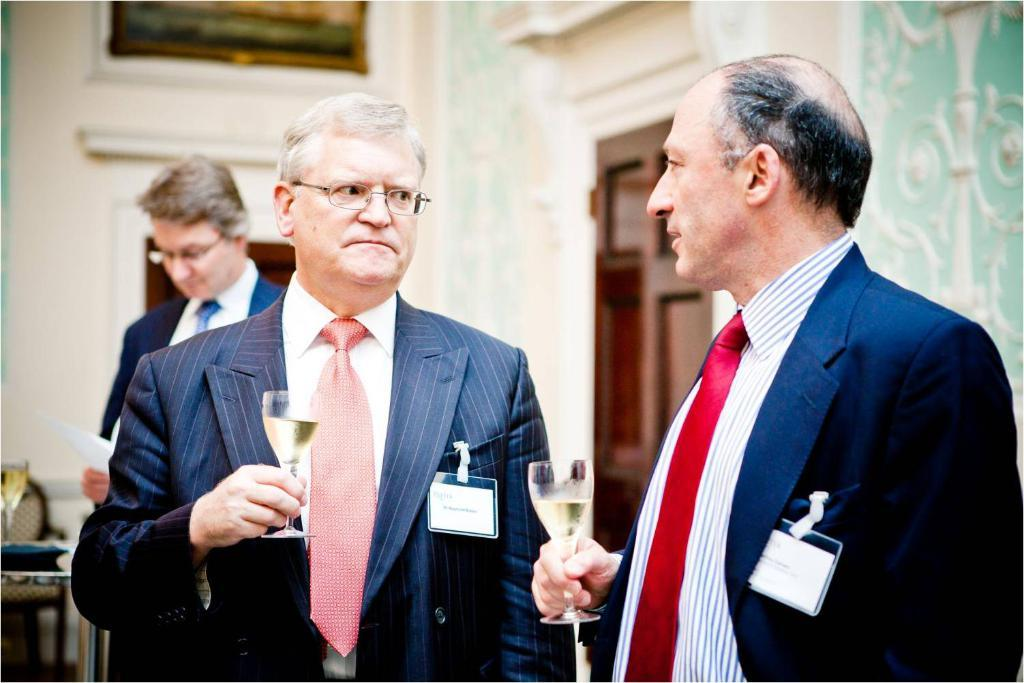How many men are present in the image? There are two men standing in the image. What are the men holding in their hands? The men are holding glasses with a drink. Can you describe the background of the image? There is a man in the background of the image. What is on a surface in the image? There is a glass on a surface in the image. What type of furniture is visible in the image? There is a chair in the image. What architectural features can be seen in the image? There is a wall and a door in the image. What type of beef can be seen on the toes of the men in the image? There is no beef or mention of toes in the image; the men are holding glasses with a drink. 